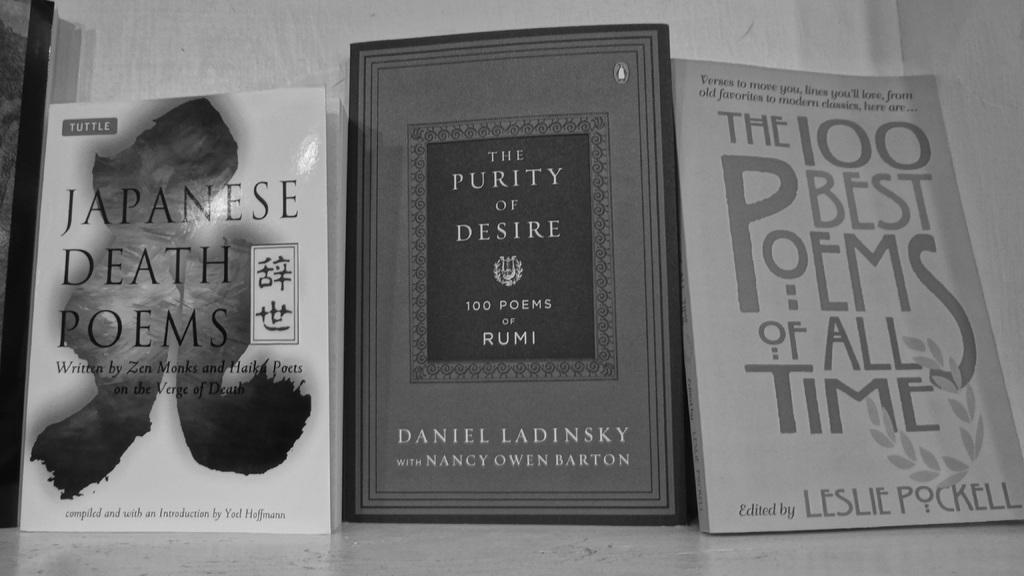<image>
Present a compact description of the photo's key features. Poetry books st side by side and one lists the 100 best poems of all time. 